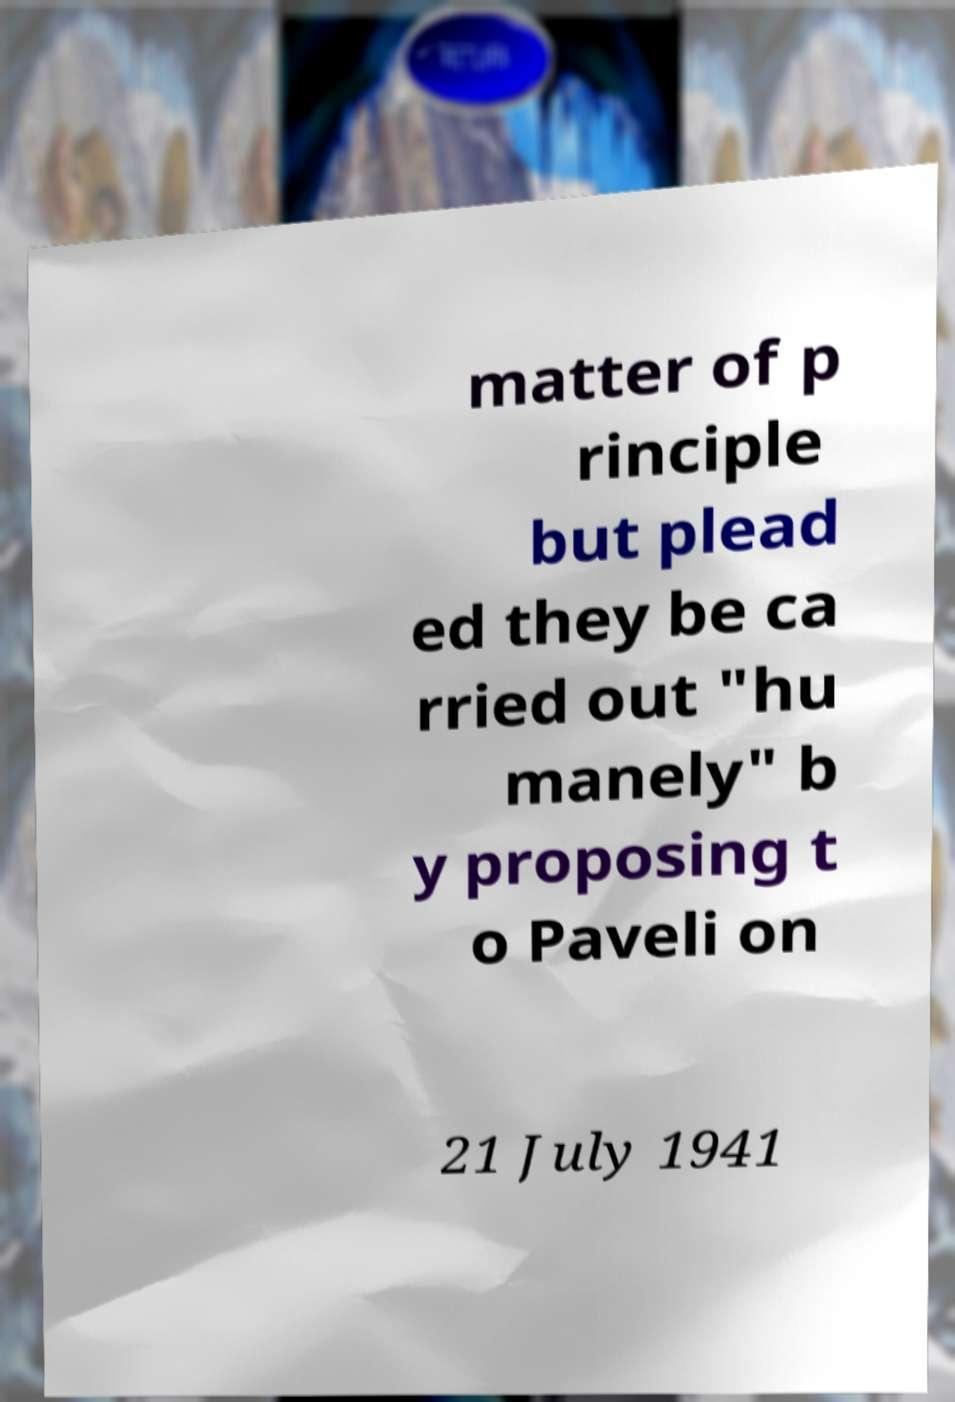What messages or text are displayed in this image? I need them in a readable, typed format. matter of p rinciple but plead ed they be ca rried out "hu manely" b y proposing t o Paveli on 21 July 1941 